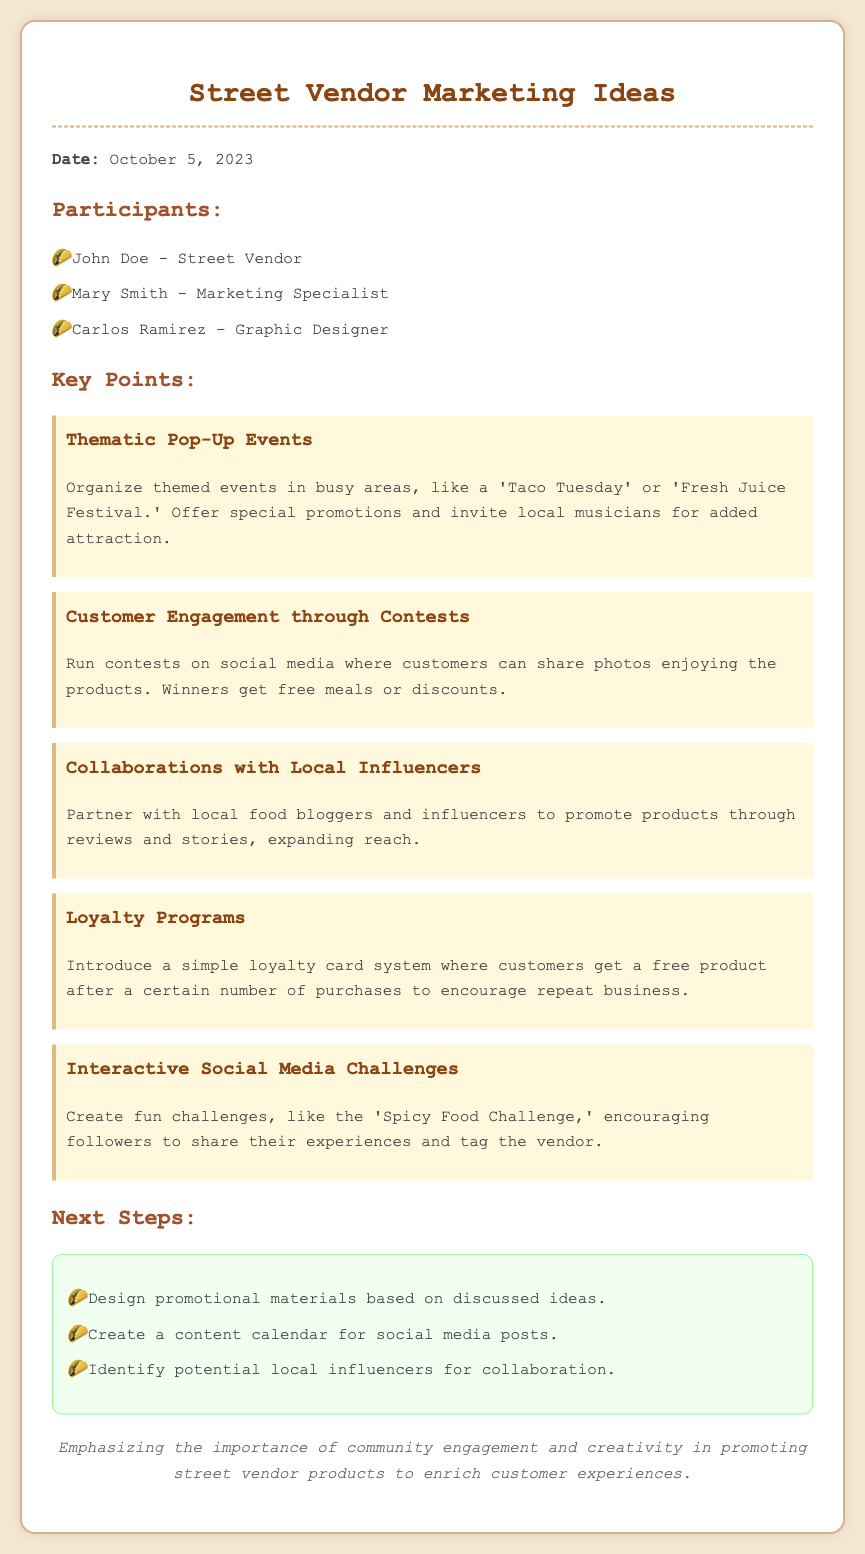What is the date of the meeting? The date of the meeting is mentioned clearly at the top of the document.
Answer: October 5, 2023 Who is the graphic designer in the meeting? The participants' names and their roles are listed in the document.
Answer: Carlos Ramirez What promotional idea involves themed events? Key points are highlighted with titles that describe each marketing idea.
Answer: Thematic Pop-Up Events How many next steps are listed in the document? The document provides a list of actions to follow up from the brainstorming session.
Answer: Three What type of program is suggested to encourage repeat business? One of the ideas discussed offers a specific type of customer program to enhance loyalty.
Answer: Loyalty Programs What social media strategy encourages sharing experiences? The document outlines various marketing ideas that include creative engagement with customers.
Answer: Interactive Social Media Challenges Which idea suggests working with local food bloggers? The title of the idea indicates the focus on collaboration with social media figures for promotion.
Answer: Collaborations with Local Influencers What is the closing remark emphasizing? The closing statement summarizes the overall intention behind the meeting's ideas.
Answer: Community engagement and creativity 